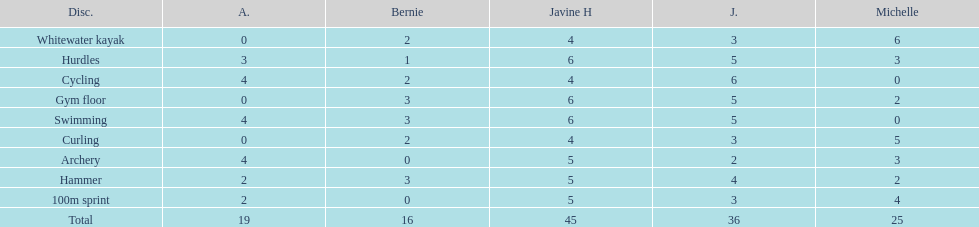Who earned the most total points? Javine H. 